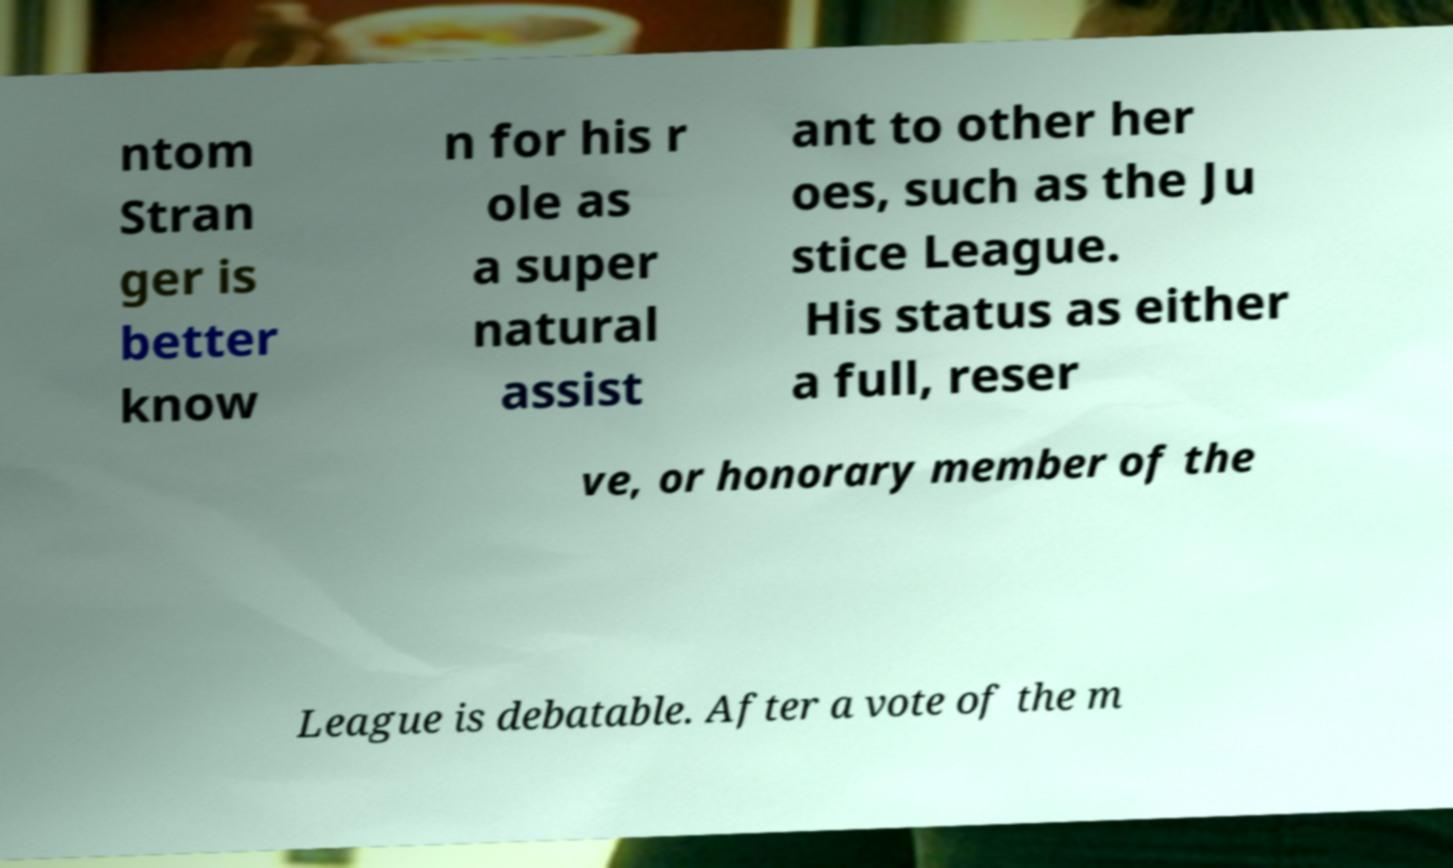Please read and relay the text visible in this image. What does it say? ntom Stran ger is better know n for his r ole as a super natural assist ant to other her oes, such as the Ju stice League. His status as either a full, reser ve, or honorary member of the League is debatable. After a vote of the m 